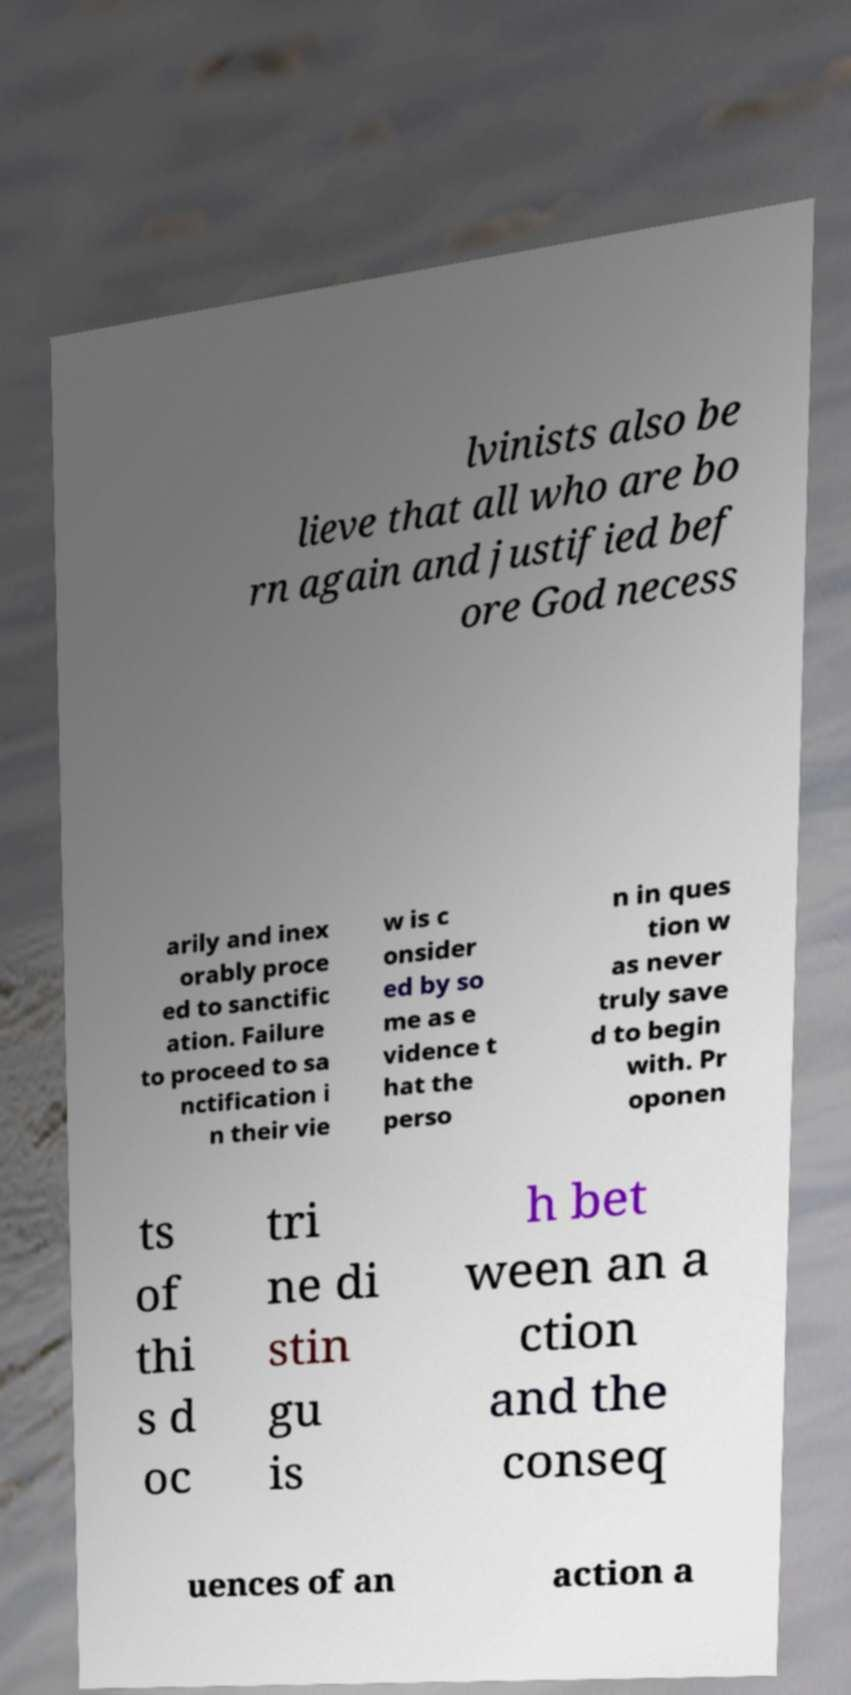Could you extract and type out the text from this image? lvinists also be lieve that all who are bo rn again and justified bef ore God necess arily and inex orably proce ed to sanctific ation. Failure to proceed to sa nctification i n their vie w is c onsider ed by so me as e vidence t hat the perso n in ques tion w as never truly save d to begin with. Pr oponen ts of thi s d oc tri ne di stin gu is h bet ween an a ction and the conseq uences of an action a 